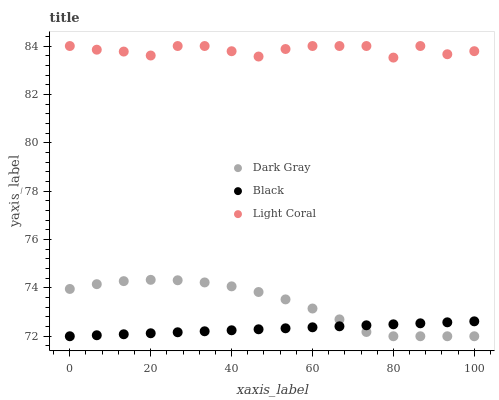Does Black have the minimum area under the curve?
Answer yes or no. Yes. Does Light Coral have the maximum area under the curve?
Answer yes or no. Yes. Does Light Coral have the minimum area under the curve?
Answer yes or no. No. Does Black have the maximum area under the curve?
Answer yes or no. No. Is Black the smoothest?
Answer yes or no. Yes. Is Light Coral the roughest?
Answer yes or no. Yes. Is Light Coral the smoothest?
Answer yes or no. No. Is Black the roughest?
Answer yes or no. No. Does Dark Gray have the lowest value?
Answer yes or no. Yes. Does Light Coral have the lowest value?
Answer yes or no. No. Does Light Coral have the highest value?
Answer yes or no. Yes. Does Black have the highest value?
Answer yes or no. No. Is Dark Gray less than Light Coral?
Answer yes or no. Yes. Is Light Coral greater than Black?
Answer yes or no. Yes. Does Black intersect Dark Gray?
Answer yes or no. Yes. Is Black less than Dark Gray?
Answer yes or no. No. Is Black greater than Dark Gray?
Answer yes or no. No. Does Dark Gray intersect Light Coral?
Answer yes or no. No. 